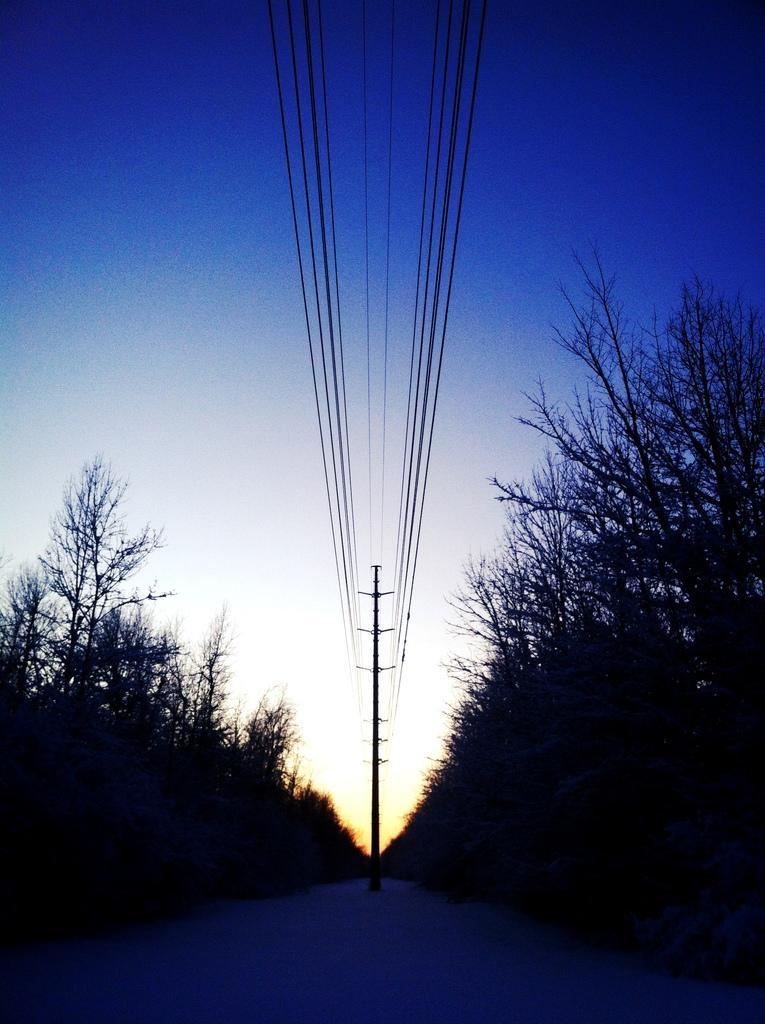In one or two sentences, can you explain what this image depicts? This image is dark where we can see trees on the either side, pole in the center and wires here. On the top of the image we can see the blue color sky. 